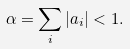<formula> <loc_0><loc_0><loc_500><loc_500>\alpha = \sum _ { i } | a _ { i } | < 1 .</formula> 